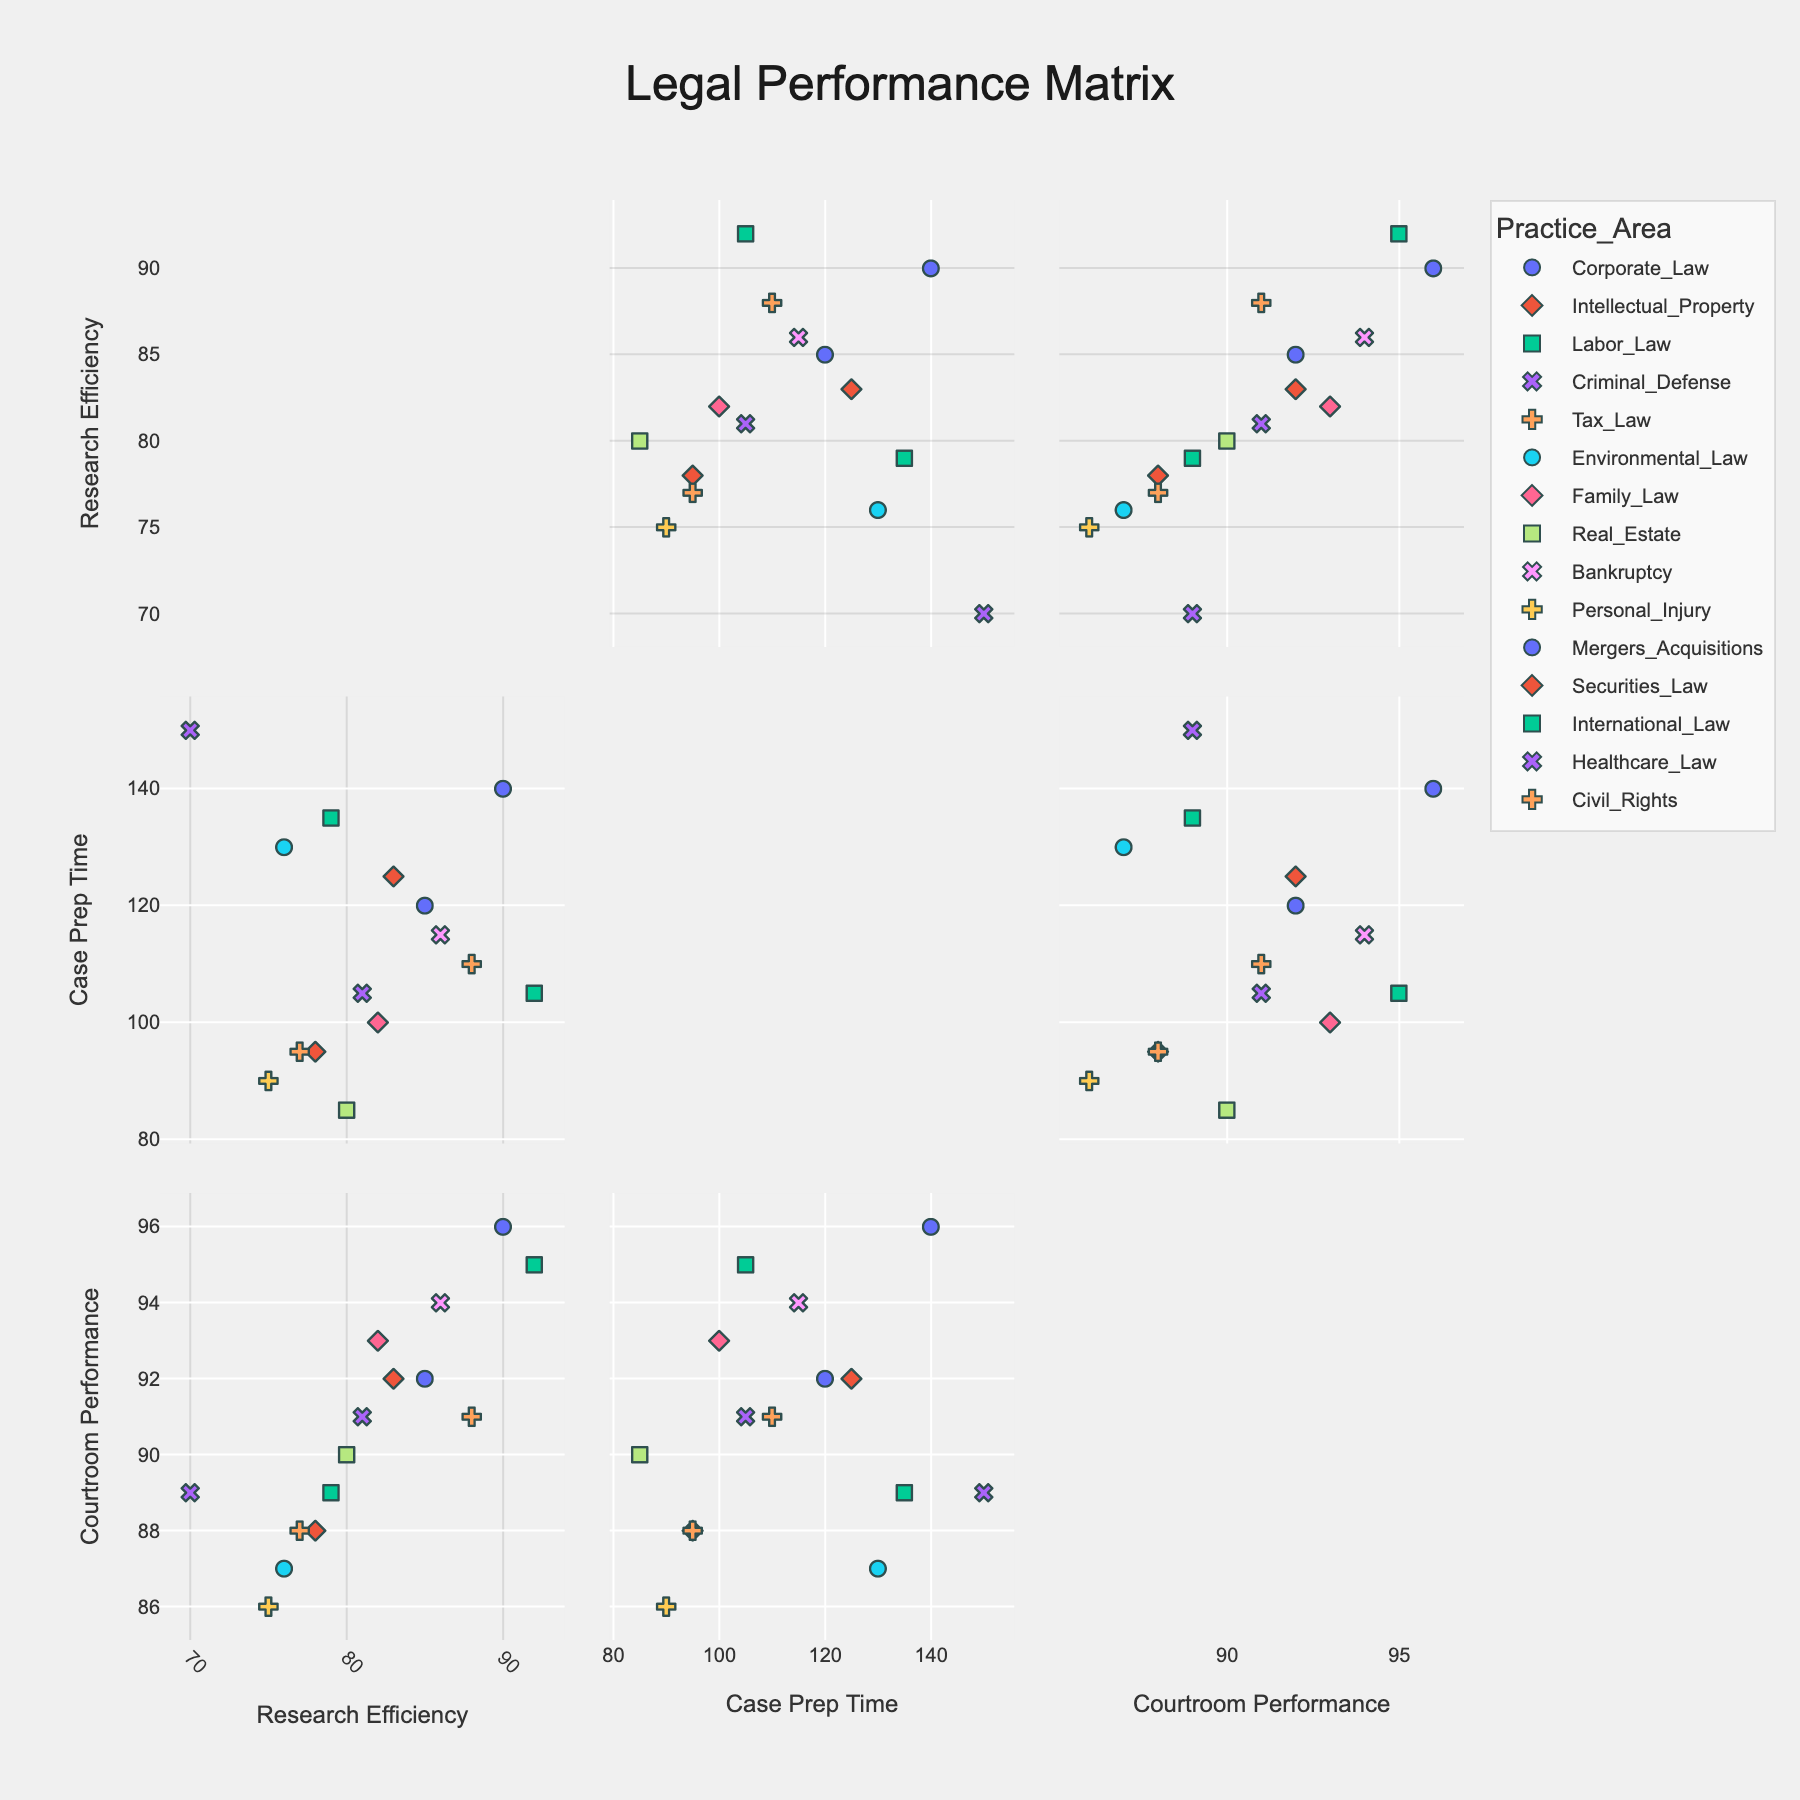What's the title of the figure? The title is prominently displayed at the top of the figure.
Answer: Urban Population Density Changes (1950-2020) Which city had the highest population density in 1980? Look at the subplots for each city and identify the highest value for the year 1980. The highest peak on the y-axis for 1980 is São Paulo.
Answer: São Paulo Which city had the slowest growth in population density from 1950 to 2020? Calculate the difference between the population density in 1950 and 2020 for each city, then identify the smallest value. For London: 9304-5130=4174, which is the smallest change.
Answer: London Comparing Tokyo and Mumbai, which city had a greater population density in 1990? Check the population density values in 1990 for both Tokyo and Mumbai from their respective subplots. Tokyo: 11855, Mumbai: 12436, so Mumbai is greater.
Answer: Mumbai What was the approximate average population density of São Paulo from 1950 to 1980? Average = (sum of population density from 1950, 1960, 1970, and 1980)/4. São Paulo: (2334+3781+8140+12089)/4= 65.19.25  = 65.24
Answer: 6544 How did the population density of Shanghai change between 1970 and 1980? Look at Shanghai's values for 1970 and 1980, then subtract the 1970 value from the 1980 value. 11739 (1980) - 7496 (1970) = 4243
Answer: 4243 What is the color of the line representing Tokyo? Identify the color used in the subplot for Tokyo. Tokyo is represented in light blue color.
Answer: Light Blue 